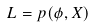<formula> <loc_0><loc_0><loc_500><loc_500>L = p ( \phi , X )</formula> 